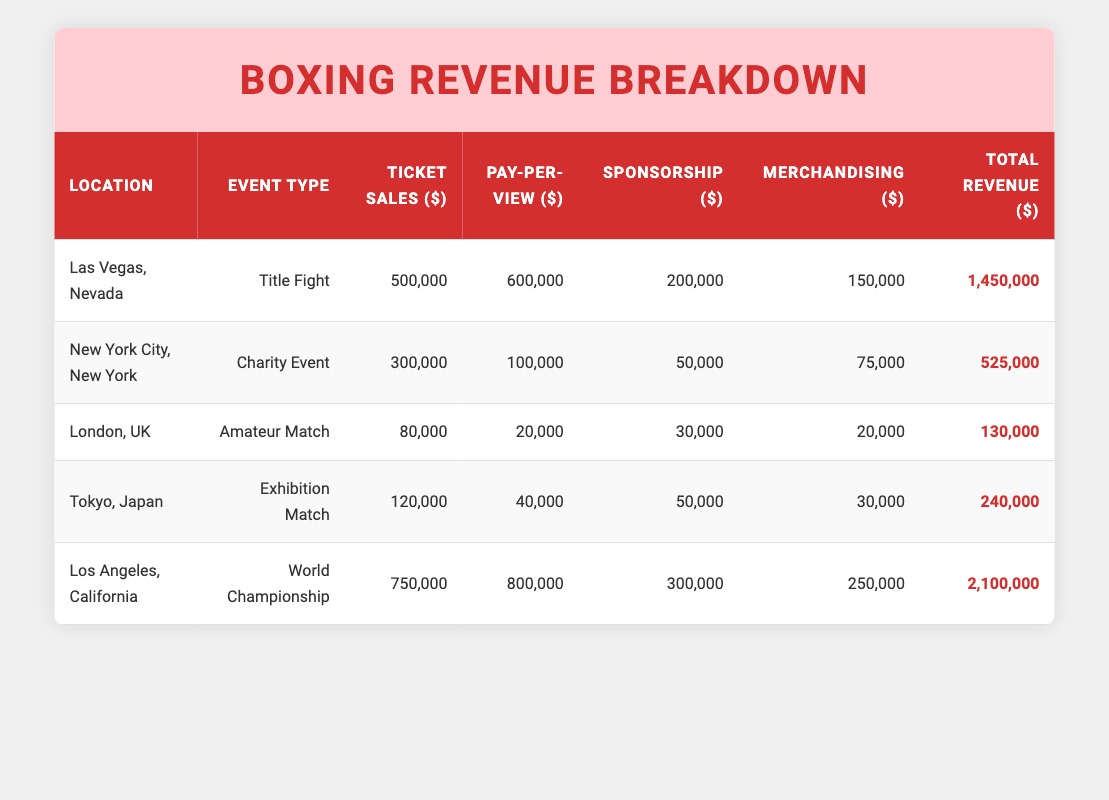What is the total revenue generated from the boxing event in Las Vegas? According to the table, the total revenue from the Las Vegas event is found in the row under "Total Revenue ($)", which states 1,450,000.
Answer: 1,450,000 Which location had the highest merchandising revenue? The merchandising revenue values are: Las Vegas (150,000), New York City (75,000), London (20,000), Tokyo (30,000), and Los Angeles (250,000). Comparing these, Los Angeles has the highest merchandising revenue of 250,000.
Answer: Los Angeles Is the total revenue from the World Championship in Los Angeles greater than the combined total revenue of the Charity Event in New York City and the Exhibition Match in Tokyo? The World Championship revenue is 2,100,000. The Charity Event has a total revenue of 525,000, and the Exhibition Match has 240,000. Adding these gives 525,000 + 240,000 = 765,000. Since 2,100,000 is greater than 765,000, the answer is yes.
Answer: Yes What is the average ticket sales revenue from all listed events? The ticket sales revenues are: 500,000 (Las Vegas), 300,000 (New York City), 80,000 (London), 120,000 (Tokyo), and 750,000 (Los Angeles). Sum them up: 500,000 + 300,000 + 80,000 + 120,000 + 750,000 = 1,750,000. There are 5 events, so the average is 1,750,000 / 5 = 350,000.
Answer: 350,000 Does the sponsorship revenue for the Title Fight in Las Vegas exceed the merchandising revenue for the Amateur Match in London? The sponsorship revenue for the Title Fight in Las Vegas is 200,000, while the merchandising revenue for the Amateur Match in London is 20,000. Since 200,000 is greater than 20,000, the answer is yes.
Answer: Yes 